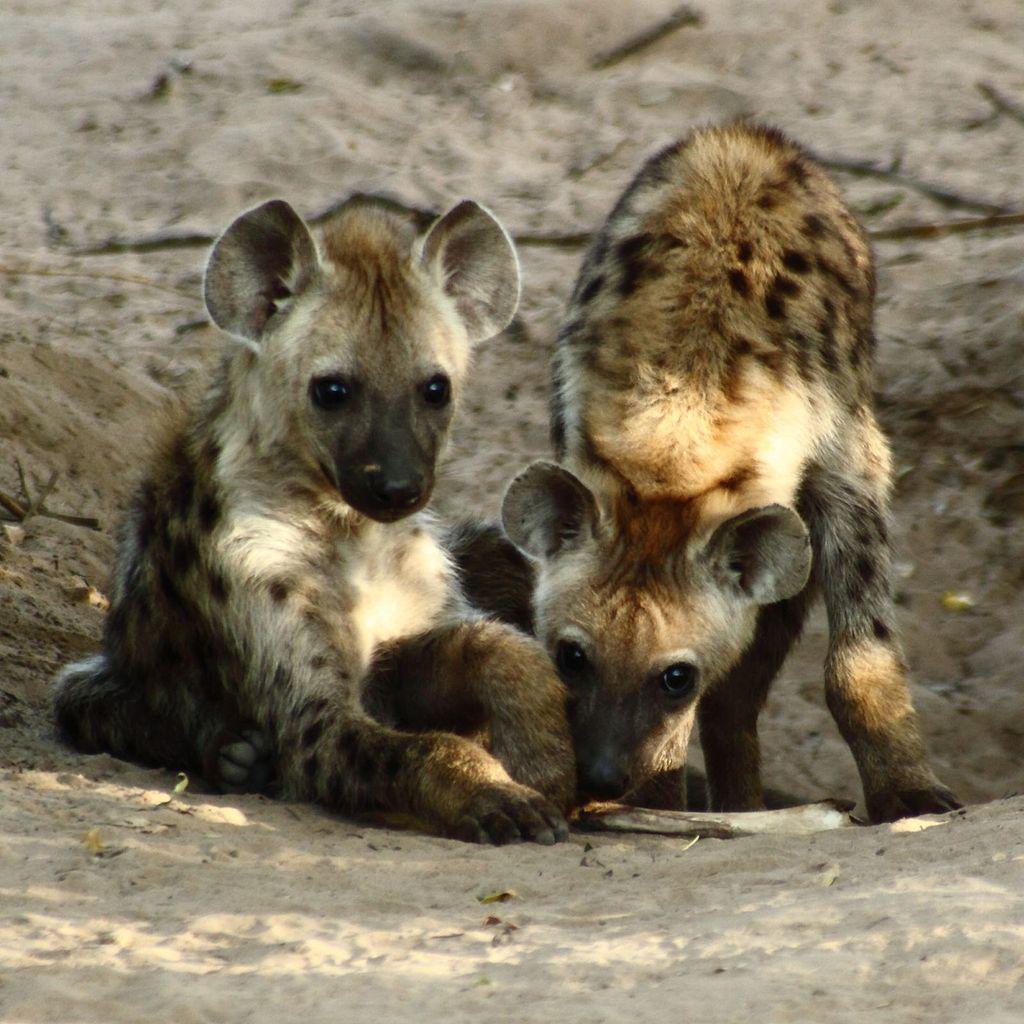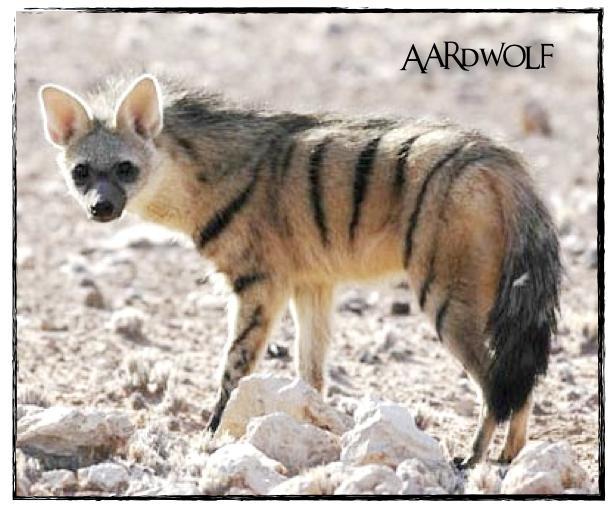The first image is the image on the left, the second image is the image on the right. Analyze the images presented: Is the assertion "There is a single hyena in each of the images." valid? Answer yes or no. No. The first image is the image on the left, the second image is the image on the right. Evaluate the accuracy of this statement regarding the images: "One image shows a dog-like animal walking with its body and head in profile and its hindquarters sloped lower than its shoulders.". Is it true? Answer yes or no. No. 